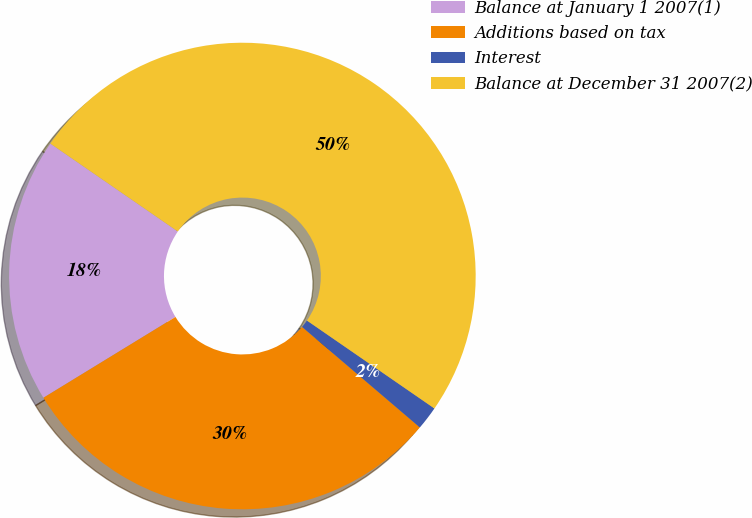Convert chart. <chart><loc_0><loc_0><loc_500><loc_500><pie_chart><fcel>Balance at January 1 2007(1)<fcel>Additions based on tax<fcel>Interest<fcel>Balance at December 31 2007(2)<nl><fcel>18.35%<fcel>30.02%<fcel>1.63%<fcel>50.0%<nl></chart> 